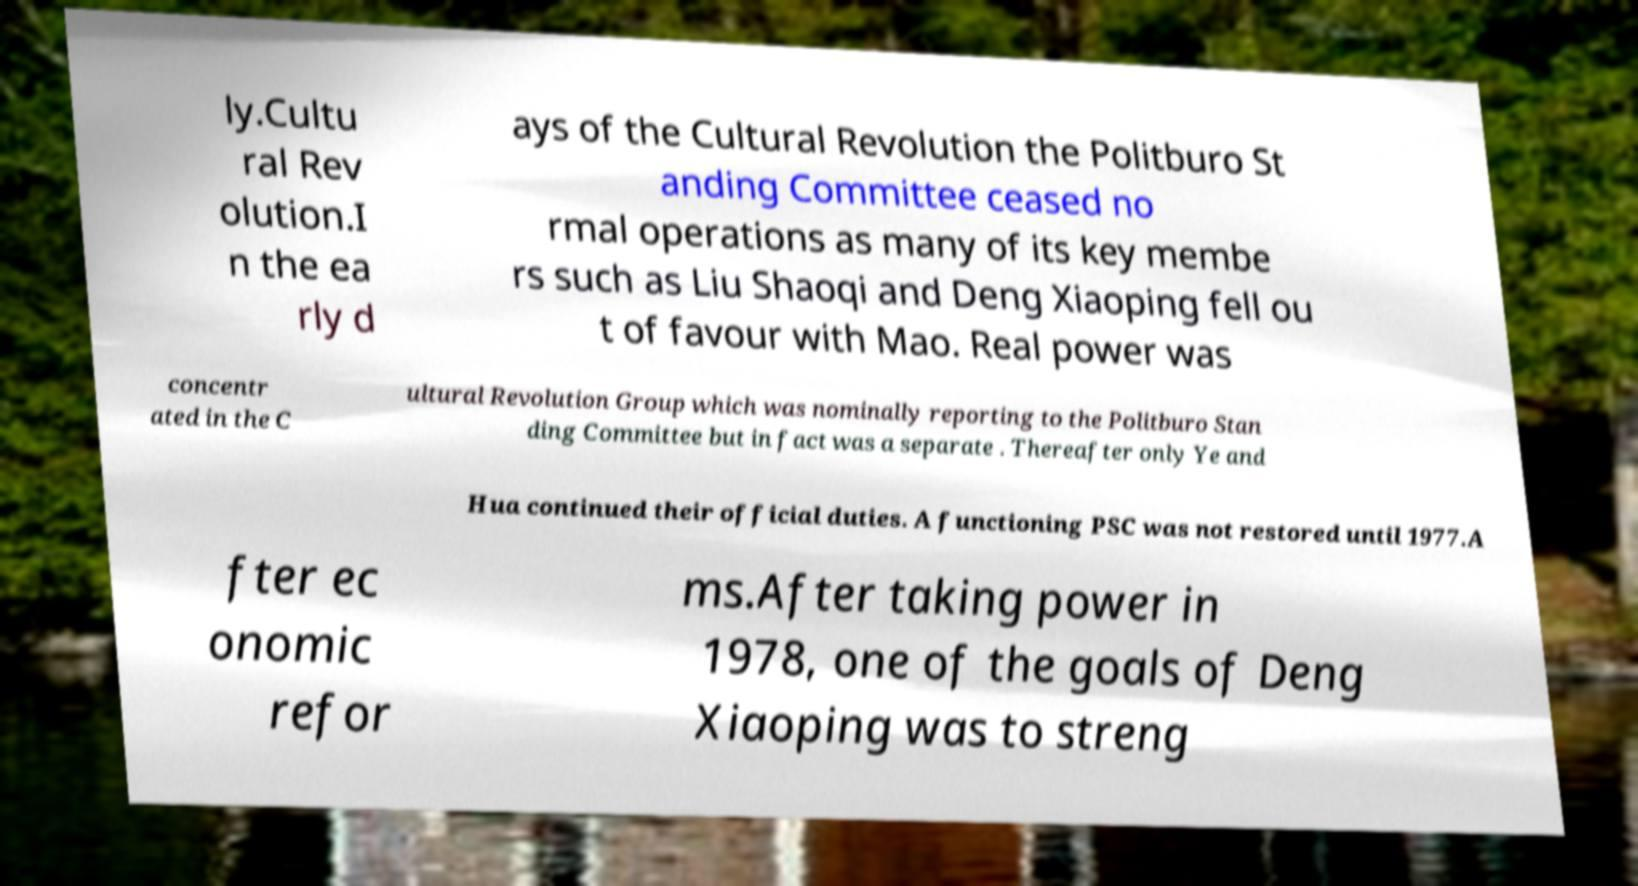There's text embedded in this image that I need extracted. Can you transcribe it verbatim? ly.Cultu ral Rev olution.I n the ea rly d ays of the Cultural Revolution the Politburo St anding Committee ceased no rmal operations as many of its key membe rs such as Liu Shaoqi and Deng Xiaoping fell ou t of favour with Mao. Real power was concentr ated in the C ultural Revolution Group which was nominally reporting to the Politburo Stan ding Committee but in fact was a separate . Thereafter only Ye and Hua continued their official duties. A functioning PSC was not restored until 1977.A fter ec onomic refor ms.After taking power in 1978, one of the goals of Deng Xiaoping was to streng 